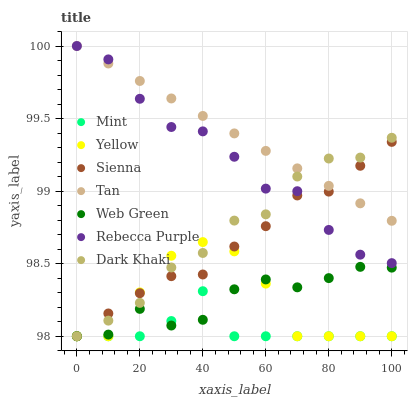Does Mint have the minimum area under the curve?
Answer yes or no. Yes. Does Tan have the maximum area under the curve?
Answer yes or no. Yes. Does Web Green have the minimum area under the curve?
Answer yes or no. No. Does Web Green have the maximum area under the curve?
Answer yes or no. No. Is Tan the smoothest?
Answer yes or no. Yes. Is Yellow the roughest?
Answer yes or no. Yes. Is Web Green the smoothest?
Answer yes or no. No. Is Web Green the roughest?
Answer yes or no. No. Does Dark Khaki have the lowest value?
Answer yes or no. Yes. Does Tan have the lowest value?
Answer yes or no. No. Does Rebecca Purple have the highest value?
Answer yes or no. Yes. Does Web Green have the highest value?
Answer yes or no. No. Is Web Green less than Tan?
Answer yes or no. Yes. Is Rebecca Purple greater than Yellow?
Answer yes or no. Yes. Does Yellow intersect Mint?
Answer yes or no. Yes. Is Yellow less than Mint?
Answer yes or no. No. Is Yellow greater than Mint?
Answer yes or no. No. Does Web Green intersect Tan?
Answer yes or no. No. 